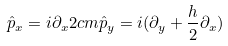Convert formula to latex. <formula><loc_0><loc_0><loc_500><loc_500>\hat { p } _ { x } = i \partial _ { x } 2 c m \hat { p } _ { y } = i ( \partial _ { y } + \frac { h } { 2 } \partial _ { x } )</formula> 